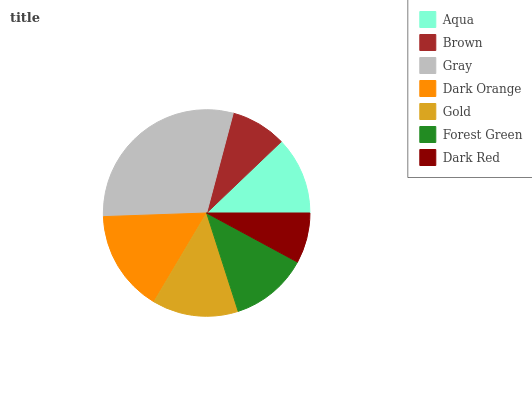Is Dark Red the minimum?
Answer yes or no. Yes. Is Gray the maximum?
Answer yes or no. Yes. Is Brown the minimum?
Answer yes or no. No. Is Brown the maximum?
Answer yes or no. No. Is Aqua greater than Brown?
Answer yes or no. Yes. Is Brown less than Aqua?
Answer yes or no. Yes. Is Brown greater than Aqua?
Answer yes or no. No. Is Aqua less than Brown?
Answer yes or no. No. Is Forest Green the high median?
Answer yes or no. Yes. Is Forest Green the low median?
Answer yes or no. Yes. Is Gold the high median?
Answer yes or no. No. Is Gold the low median?
Answer yes or no. No. 